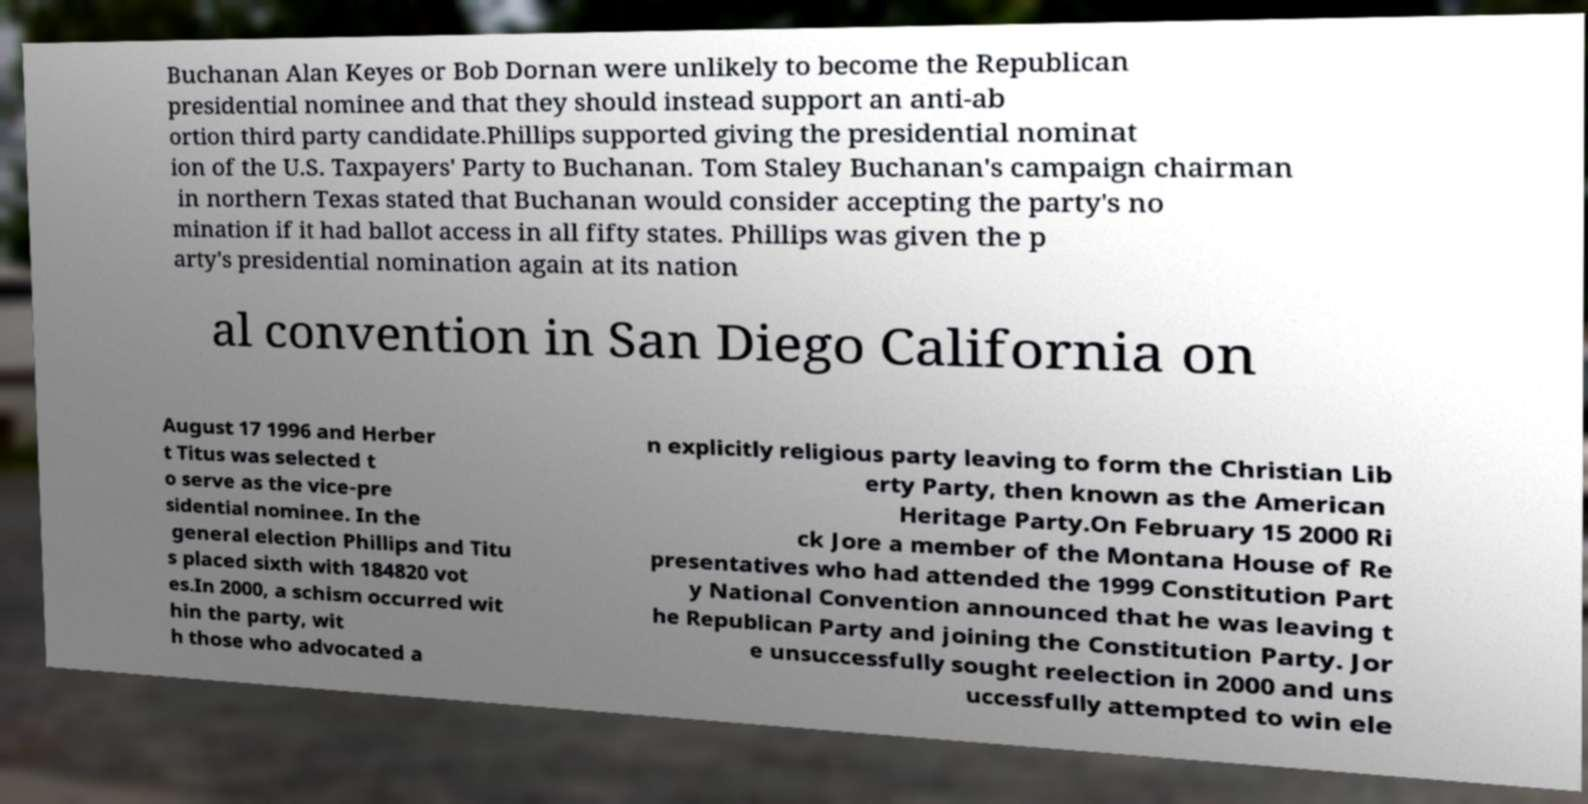Please read and relay the text visible in this image. What does it say? Buchanan Alan Keyes or Bob Dornan were unlikely to become the Republican presidential nominee and that they should instead support an anti-ab ortion third party candidate.Phillips supported giving the presidential nominat ion of the U.S. Taxpayers' Party to Buchanan. Tom Staley Buchanan's campaign chairman in northern Texas stated that Buchanan would consider accepting the party's no mination if it had ballot access in all fifty states. Phillips was given the p arty's presidential nomination again at its nation al convention in San Diego California on August 17 1996 and Herber t Titus was selected t o serve as the vice-pre sidential nominee. In the general election Phillips and Titu s placed sixth with 184820 vot es.In 2000, a schism occurred wit hin the party, wit h those who advocated a n explicitly religious party leaving to form the Christian Lib erty Party, then known as the American Heritage Party.On February 15 2000 Ri ck Jore a member of the Montana House of Re presentatives who had attended the 1999 Constitution Part y National Convention announced that he was leaving t he Republican Party and joining the Constitution Party. Jor e unsuccessfully sought reelection in 2000 and uns uccessfully attempted to win ele 